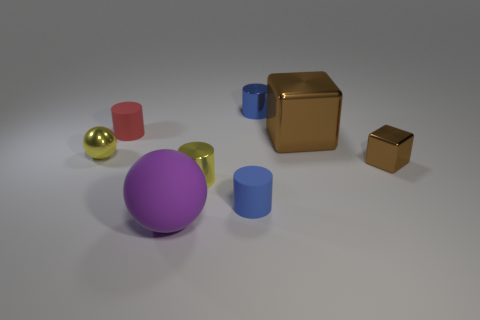Add 2 blue cylinders. How many objects exist? 10 Subtract all balls. How many objects are left? 6 Subtract 0 cyan cubes. How many objects are left? 8 Subtract all tiny green rubber cylinders. Subtract all small yellow things. How many objects are left? 6 Add 2 big spheres. How many big spheres are left? 3 Add 8 purple rubber objects. How many purple rubber objects exist? 9 